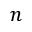<formula> <loc_0><loc_0><loc_500><loc_500>n</formula> 